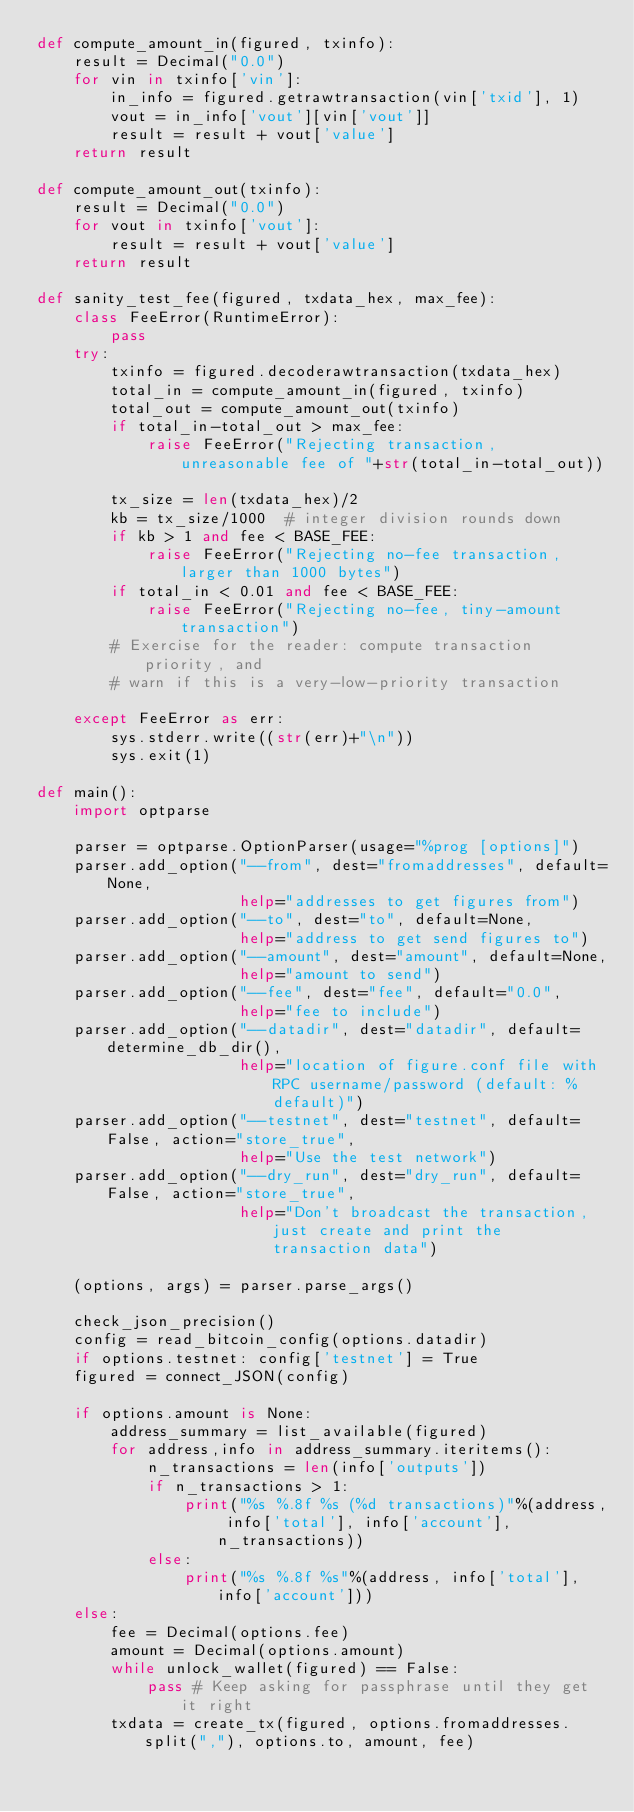<code> <loc_0><loc_0><loc_500><loc_500><_Python_>def compute_amount_in(figured, txinfo):
    result = Decimal("0.0")
    for vin in txinfo['vin']:
        in_info = figured.getrawtransaction(vin['txid'], 1)
        vout = in_info['vout'][vin['vout']]
        result = result + vout['value']
    return result

def compute_amount_out(txinfo):
    result = Decimal("0.0")
    for vout in txinfo['vout']:
        result = result + vout['value']
    return result

def sanity_test_fee(figured, txdata_hex, max_fee):
    class FeeError(RuntimeError):
        pass
    try:
        txinfo = figured.decoderawtransaction(txdata_hex)
        total_in = compute_amount_in(figured, txinfo)
        total_out = compute_amount_out(txinfo)
        if total_in-total_out > max_fee:
            raise FeeError("Rejecting transaction, unreasonable fee of "+str(total_in-total_out))

        tx_size = len(txdata_hex)/2
        kb = tx_size/1000  # integer division rounds down
        if kb > 1 and fee < BASE_FEE:
            raise FeeError("Rejecting no-fee transaction, larger than 1000 bytes")
        if total_in < 0.01 and fee < BASE_FEE:
            raise FeeError("Rejecting no-fee, tiny-amount transaction")
        # Exercise for the reader: compute transaction priority, and
        # warn if this is a very-low-priority transaction

    except FeeError as err:
        sys.stderr.write((str(err)+"\n"))
        sys.exit(1)

def main():
    import optparse

    parser = optparse.OptionParser(usage="%prog [options]")
    parser.add_option("--from", dest="fromaddresses", default=None,
                      help="addresses to get figures from")
    parser.add_option("--to", dest="to", default=None,
                      help="address to get send figures to")
    parser.add_option("--amount", dest="amount", default=None,
                      help="amount to send")
    parser.add_option("--fee", dest="fee", default="0.0",
                      help="fee to include")
    parser.add_option("--datadir", dest="datadir", default=determine_db_dir(),
                      help="location of figure.conf file with RPC username/password (default: %default)")
    parser.add_option("--testnet", dest="testnet", default=False, action="store_true",
                      help="Use the test network")
    parser.add_option("--dry_run", dest="dry_run", default=False, action="store_true",
                      help="Don't broadcast the transaction, just create and print the transaction data")

    (options, args) = parser.parse_args()

    check_json_precision()
    config = read_bitcoin_config(options.datadir)
    if options.testnet: config['testnet'] = True
    figured = connect_JSON(config)

    if options.amount is None:
        address_summary = list_available(figured)
        for address,info in address_summary.iteritems():
            n_transactions = len(info['outputs'])
            if n_transactions > 1:
                print("%s %.8f %s (%d transactions)"%(address, info['total'], info['account'], n_transactions))
            else:
                print("%s %.8f %s"%(address, info['total'], info['account']))
    else:
        fee = Decimal(options.fee)
        amount = Decimal(options.amount)
        while unlock_wallet(figured) == False:
            pass # Keep asking for passphrase until they get it right
        txdata = create_tx(figured, options.fromaddresses.split(","), options.to, amount, fee)</code> 